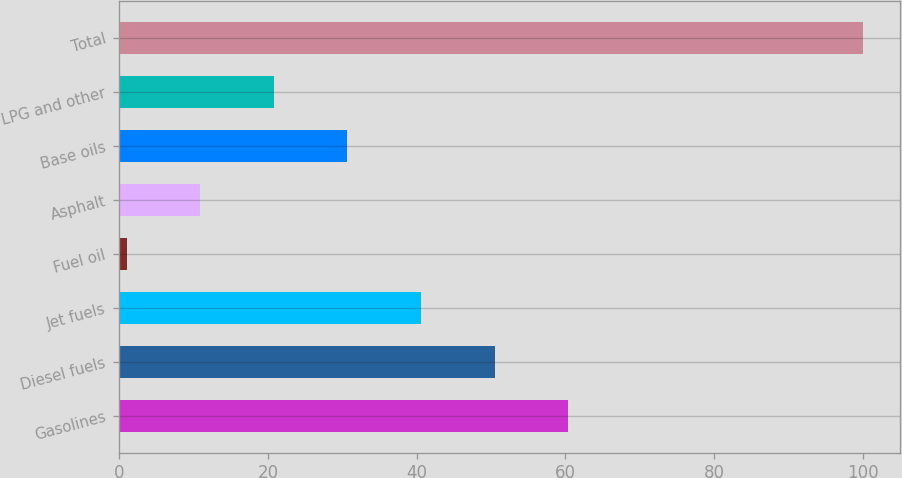Convert chart. <chart><loc_0><loc_0><loc_500><loc_500><bar_chart><fcel>Gasolines<fcel>Diesel fuels<fcel>Jet fuels<fcel>Fuel oil<fcel>Asphalt<fcel>Base oils<fcel>LPG and other<fcel>Total<nl><fcel>60.4<fcel>50.5<fcel>40.6<fcel>1<fcel>10.9<fcel>30.7<fcel>20.8<fcel>100<nl></chart> 